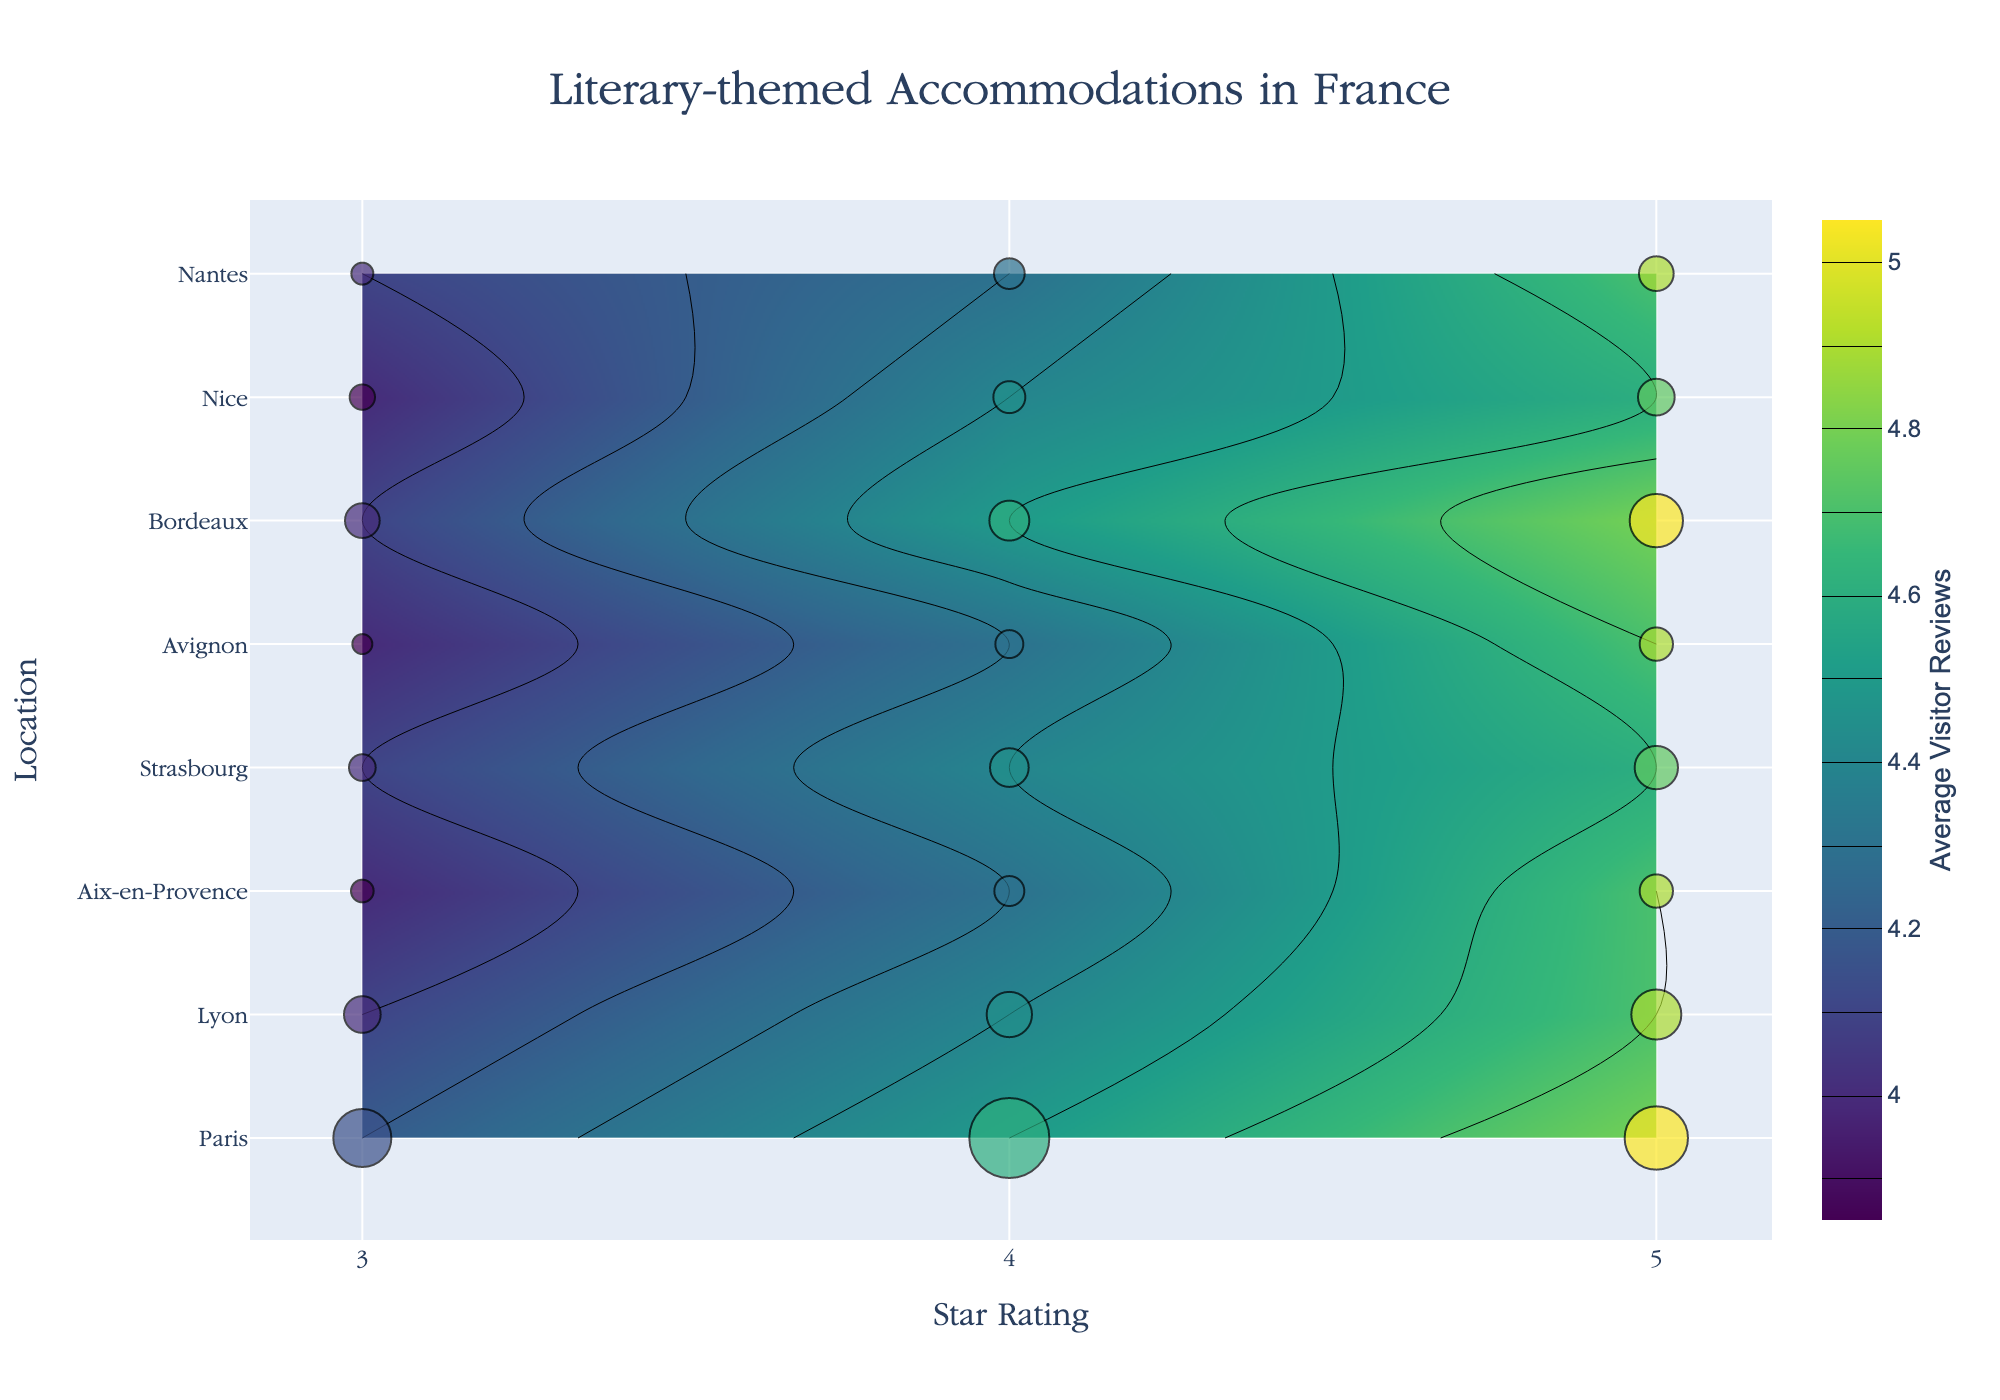What's the title of the figure? The title is typically placed at the top of the figure and is designed to give an overview of the information displayed. In this case, it reads "Literary-themed Accommodations in France."
Answer: Literary-themed Accommodations in France What's the axis label for the x-axis? The x-axis represents the star rating of the accommodations, which is explicitly labeled as "Star Rating."
Answer: Star Rating How many unique locations are displayed on the y-axis? The y-axis shows different cities. By counting the unique city names listed vertically, we can identify the number of distinct locations.
Answer: 7 In which city does the 5-star rating have the highest average visitor review? By observing the contours and markers, we look for the highest review value among the 5-star rated accommodations across all cities. Paris has an average visitor review of 4.8 for 5-star accommodations, which is the highest.
Answer: Paris Compare the average visitor reviews of 4-star and 5-star accommodations in Lyon. Which is higher and by how much? The plot shows that the 4-star accommodations in Lyon have an average visitor review of 4.4, while the 5-star accommodations have 4.7. The difference is 0.3.
Answer: 5-star by 0.3 Which city has the highest number of reviews for 4-star accommodations, and how do you know? By examining the size of the markers, the largest marker for 4-star accommodations is in Paris, with each data point labeled with the number of reviews. Paris has 120 reviews.
Answer: Paris, 120 reviews What is the lowest average visitor review for any 3-star accommodation? By inspecting the contour lines and the markers for the 3-star accommodations, the lowest average review is seen in Aix-en-Provence and Avignon, which both have 4.0.
Answer: 4.0 Is there a city where the distribution of reviews for all accommodation levels is above 4.4? We need to look for a city where all contours for 3-star, 4-star, and 5-star accommodations show reviews above 4.4. This isn't the case for any city, as all 3-star accommodations have reviews less than or equal to 4.2.
Answer: No Which city has the smallest difference in average visitor reviews between 3-star and 5-star accommodations? By comparing the average visitor reviews for 3-star and 5-star accommodations in each city, Aix-en-Provence has a difference of 0.7 (from 4.0 to 4.7), the smallest among the cities listed.
Answer: Aix-en-Provence 